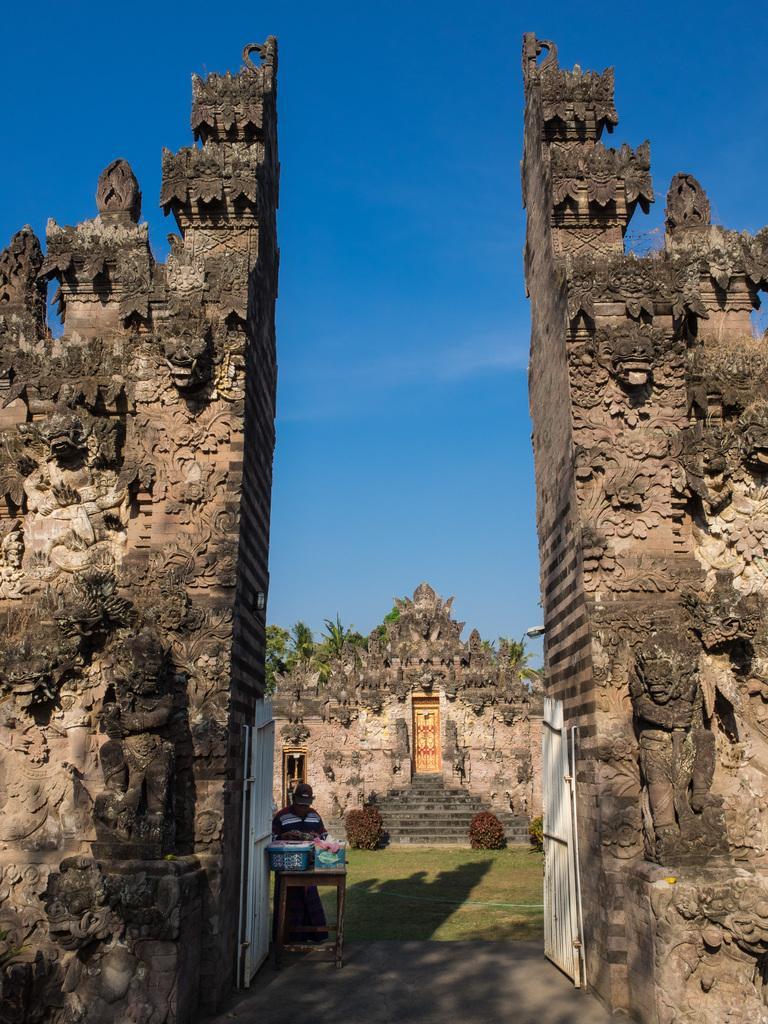Describe this image in one or two sentences. In the image there is stone on either side with an entrance in the middle followed by an ancient home in the back with grassland in front of it and trees behind it and above its sky with clouds. 